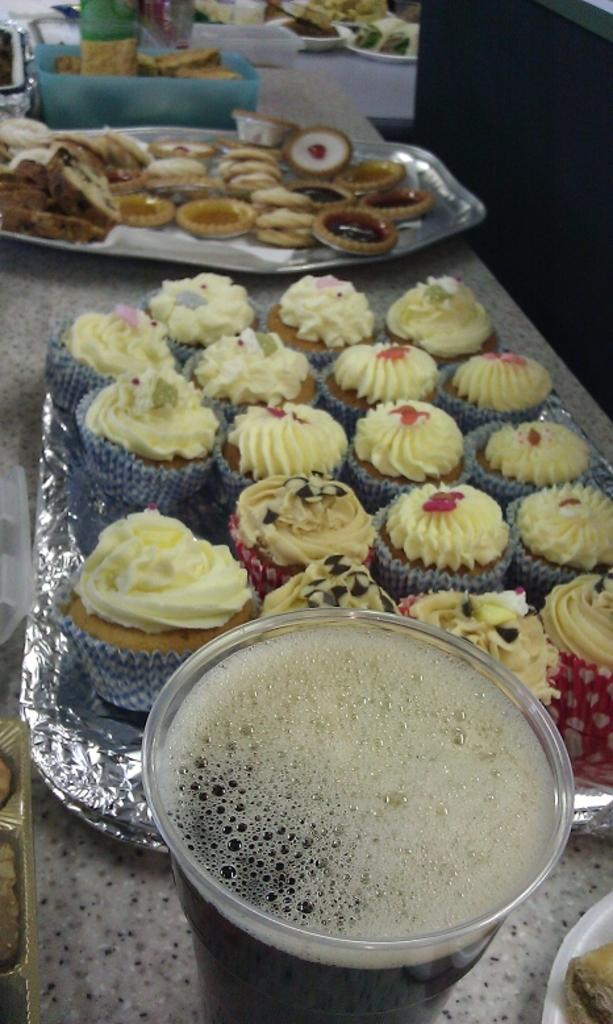What type of dessert can be seen in the image? There are cupcakes in the image. What beverage is present in the image? There is a glass of juice in the image. What surface can be seen in the image that holds various food items? There are various food items on a desk in the image. What fact about the desk's movement can be observed in the image? There is no information about the desk's movement in the image, as it is a static object. 